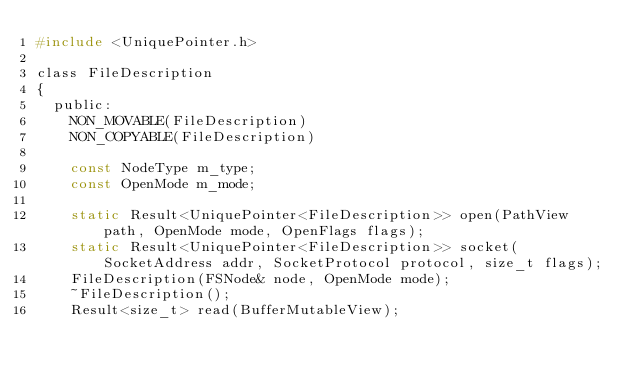<code> <loc_0><loc_0><loc_500><loc_500><_C_>#include <UniquePointer.h>

class FileDescription
{
  public:
	NON_MOVABLE(FileDescription)
	NON_COPYABLE(FileDescription)

	const NodeType m_type;
	const OpenMode m_mode;

	static Result<UniquePointer<FileDescription>> open(PathView path, OpenMode mode, OpenFlags flags);
	static Result<UniquePointer<FileDescription>> socket(SocketAddress addr, SocketProtocol protocol, size_t flags);
	FileDescription(FSNode& node, OpenMode mode);
	~FileDescription();
	Result<size_t> read(BufferMutableView);</code> 